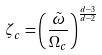<formula> <loc_0><loc_0><loc_500><loc_500>\zeta _ { c } = \left ( \frac { \tilde { \omega } } { \Omega _ { c } } \right ) ^ { \frac { d - 3 } { d - 2 } }</formula> 